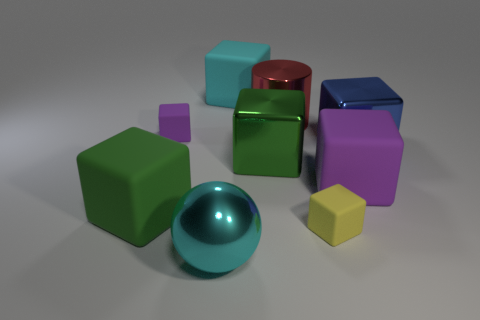Subtract all red blocks. Subtract all red cylinders. How many blocks are left? 7 Subtract all purple spheres. How many purple blocks are left? 2 Add 8 big blues. How many greens exist? 0 Subtract all cyan balls. Subtract all metal spheres. How many objects are left? 7 Add 9 large metallic cylinders. How many large metallic cylinders are left? 10 Add 1 small red matte cylinders. How many small red matte cylinders exist? 1 Add 1 big green cubes. How many objects exist? 10 Subtract all green cubes. How many cubes are left? 5 Subtract all blue cubes. How many cubes are left? 6 Subtract 0 yellow cylinders. How many objects are left? 9 